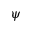Convert formula to latex. <formula><loc_0><loc_0><loc_500><loc_500>\psi</formula> 